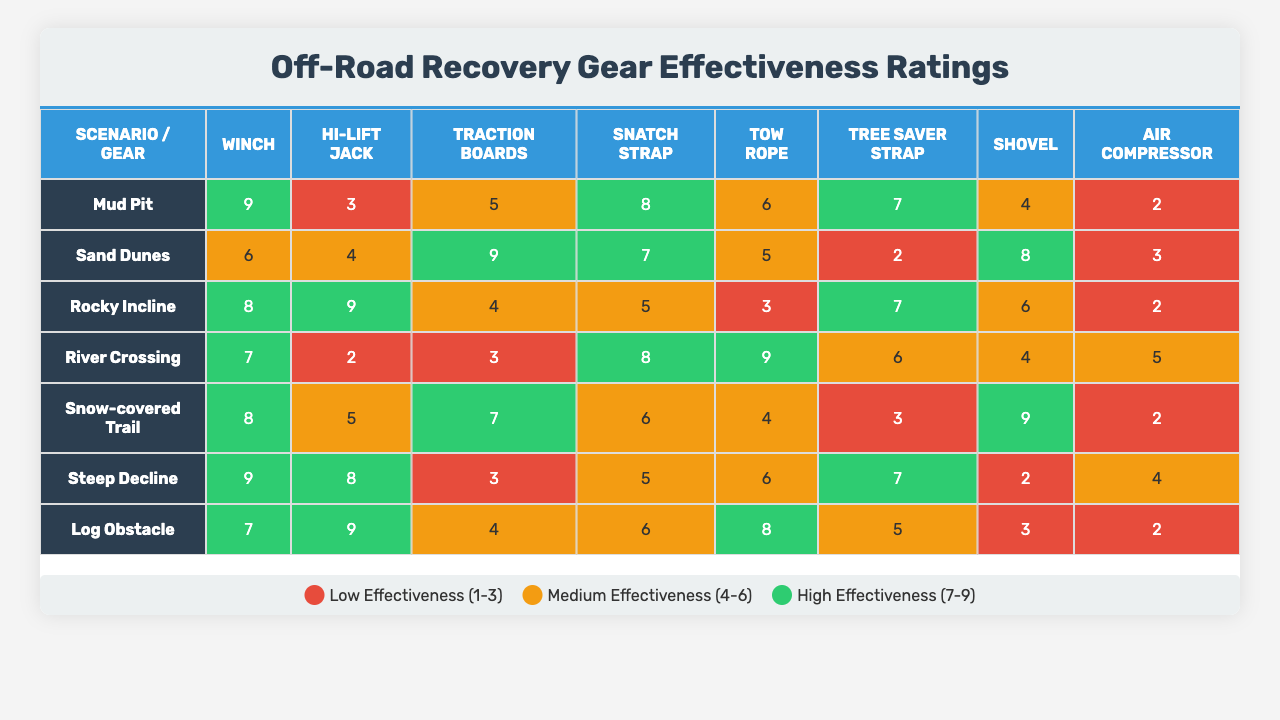What is the effectiveness rating of a winch for a muddy scenario? According to the table under the "Mud Pit" scenario, the effectiveness rating for a winch is 9.
Answer: 9 Which recovery gear has the highest rating in a sandy scenario? The effectiveness rating for both the Hi-Lift Jack and the Rocky Incline show high effectiveness, with the Hi-Lift Jack having a rating of 9. Therefore, the Hi-Lift Jack has the highest rating of 9 in the sandy scenario.
Answer: 9 Is a snatch strap rated higher than a tow rope in a river crossing scenario? In the river crossing scenario, the effectiveness rating for a snatch strap is 8, while for a tow rope, it's 5. Since 8 is greater than 5, the snatch strap is rated higher.
Answer: Yes What is the average effectiveness rating of traction boards across all scenarios? The effectiveness ratings for traction boards across all scenarios are: 5 (Mud Pit), 9 (Sand Dunes), 4 (Rocky Incline), 3 (River Crossing), 7 (Snow-covered Trail), 3 (Steep Decline), and 4 (Log Obstacle). The sum is 35, and there are 7 values: the average is 35/7 = 5.
Answer: 5 Which recovery gear is least effective in a snow-covered trail scenario? In the snow-covered trail scenario, the effectiveness rating for the air compressor is 2, which is less than the ratings for all other recovery gear in the same scenario.
Answer: Air Compressor What recovery gear has the overall highest average rating across all scenarios? To determine this, we need to calculate the average ratings for each recovery gear. The winch has average 7.14, Hi-Lift Jack 5.57, Traction Boards 5.14, Snatch Strap 6.14, Tow Rope 5.14, Tree Saver Strap 5.14, Shovel 4.14, and Air Compressor 3.14. The winch has the highest average rating of 7.14.
Answer: Winch What is the total effectiveness rating of a shovel across all scenarios? The effectiveness ratings for a shovel in each scenario are: 4 (Mud Pit), 8 (Sand Dunes), 6 (Rocky Incline), 4 (River Crossing), 9 (Snow-covered Trail), 2 (Steep Decline), and 2 (Log Obstacle). Adding these together gives a total of 35.
Answer: 35 In which scenario is the effectiveness rating of the tree saver strap rated at 2? The effectiveness rating of the tree saver strap is 2 in the sand dunes scenario, as indicated in the respective column and row for that scenario.
Answer: Sand Dunes Does the effectiveness rating for recovery gear show a trend where some gear is consistently rated low across most scenarios? Yes, after reviewing the effectiveness ratings, it is observed that the air compressor consistently shows lower ratings compared to other recovery gear across various scenarios, suggesting a trend of lower effectiveness.
Answer: Yes What is the difference between the highest and lowest ratings for the Hi-Lift Jack? The highest rating of the Hi-Lift Jack is 9 (in the sandy scenario) and the lowest is 2 (in the steep decline scenario). The difference is calculated as 9 - 2 = 7.
Answer: 7 Which piece of recovery gear has the least effective rating in a muddy scenario? In the mud pit scenario, the effectiveness rating for the air compressor is the lowest at 2, while all other gear has higher ratings.
Answer: Air Compressor 